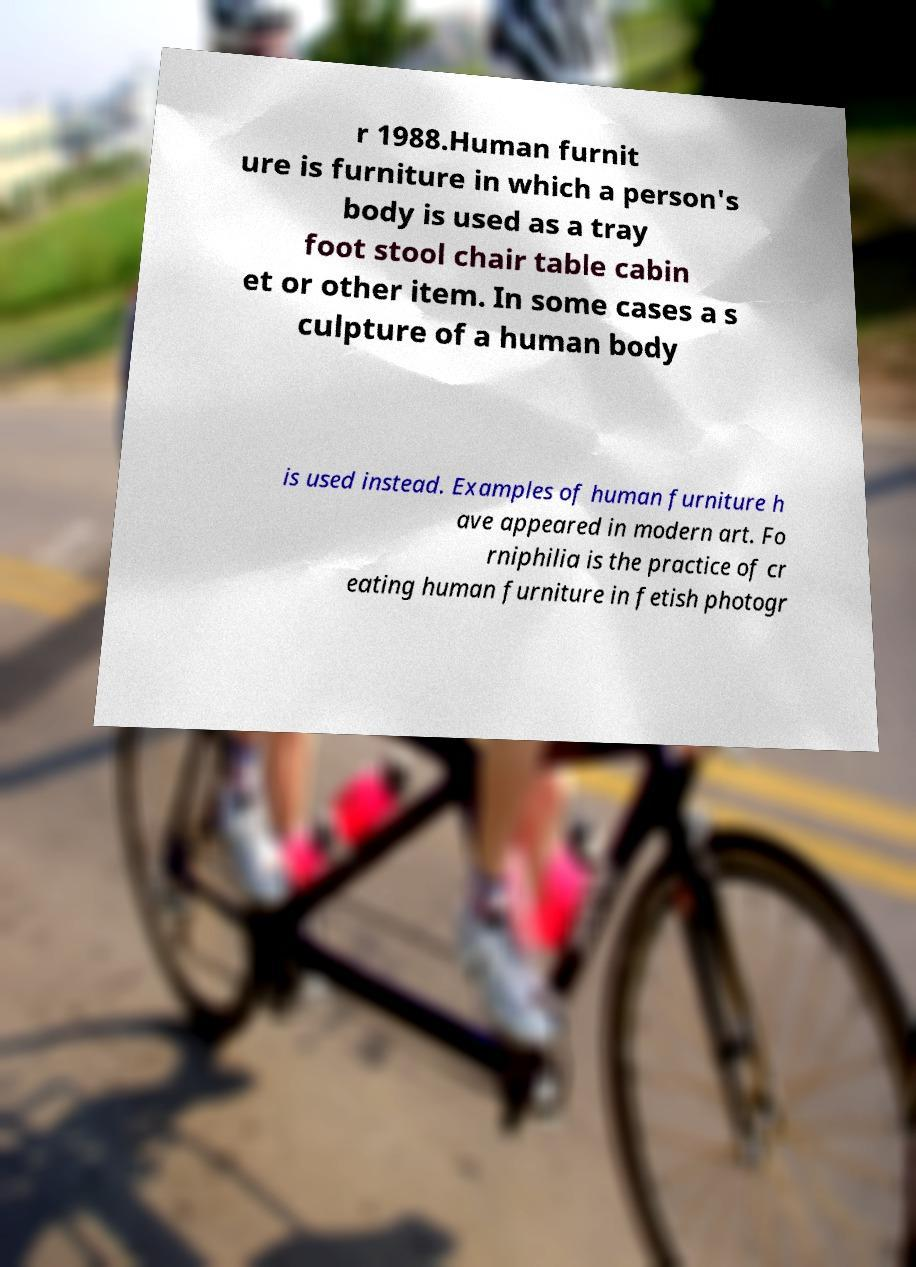Could you assist in decoding the text presented in this image and type it out clearly? r 1988.Human furnit ure is furniture in which a person's body is used as a tray foot stool chair table cabin et or other item. In some cases a s culpture of a human body is used instead. Examples of human furniture h ave appeared in modern art. Fo rniphilia is the practice of cr eating human furniture in fetish photogr 